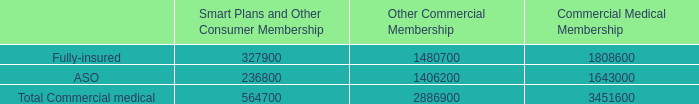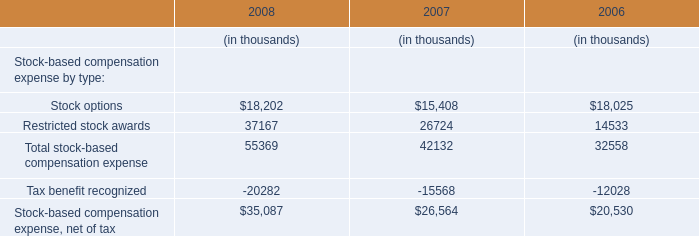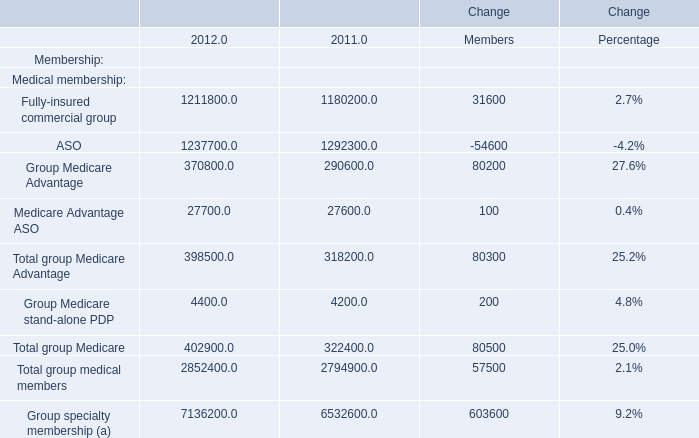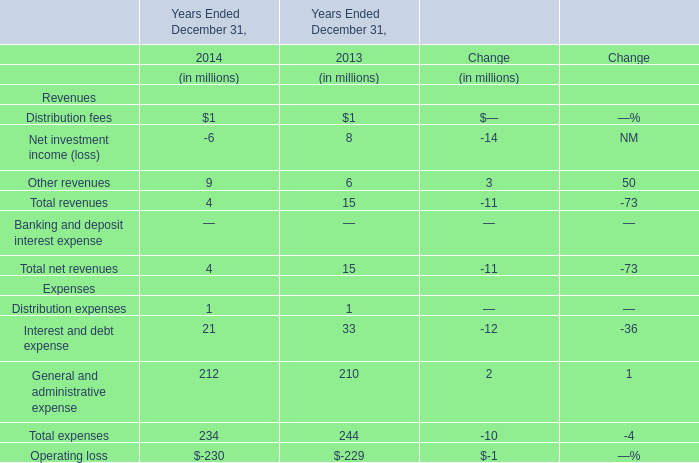as of december 2007 what was the approximate total of the total commercial medical membership 
Computations: (564700 / 16.4)
Answer: 34432.92683. 